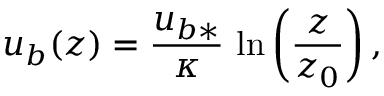Convert formula to latex. <formula><loc_0><loc_0><loc_500><loc_500>u _ { b } ( z ) = \frac { u _ { b * } } { \kappa } \, \ln \left ( \frac { z } { z _ { 0 } } \right ) ,</formula> 